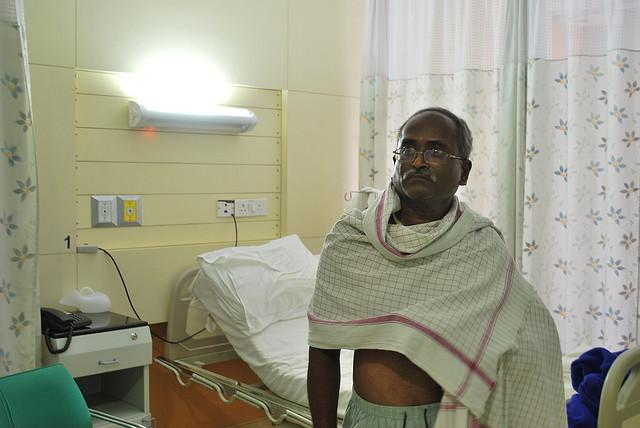This man looks most similar to what historical figure? Please explain your reasoning. mahatma gandhi. He does resemble the great philosopher of nonviolence. 